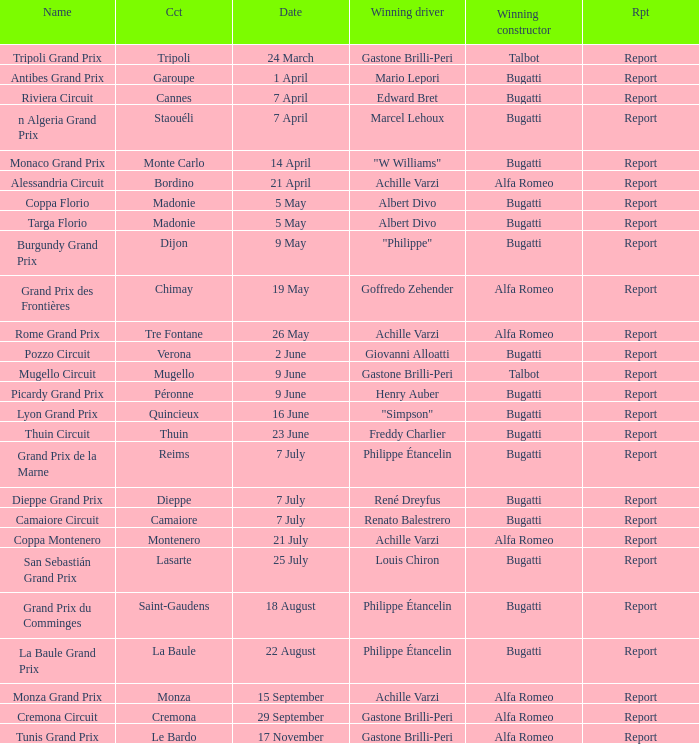What Circuit has a Winning constructor of bugatti, and a Winning driver of edward bret? Cannes. 